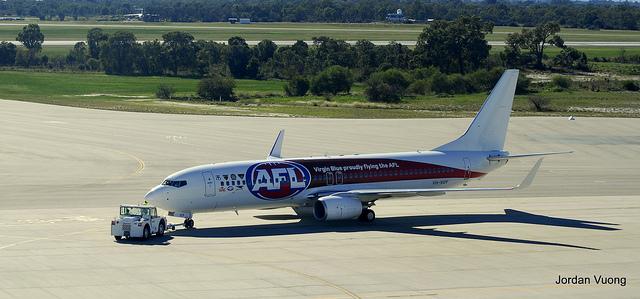What is the name of the airline?
Write a very short answer. Afl. What is the name at the bottom, right corner of the picture?
Quick response, please. Jordan vuong. Where is the airplane?
Quick response, please. On ground. 